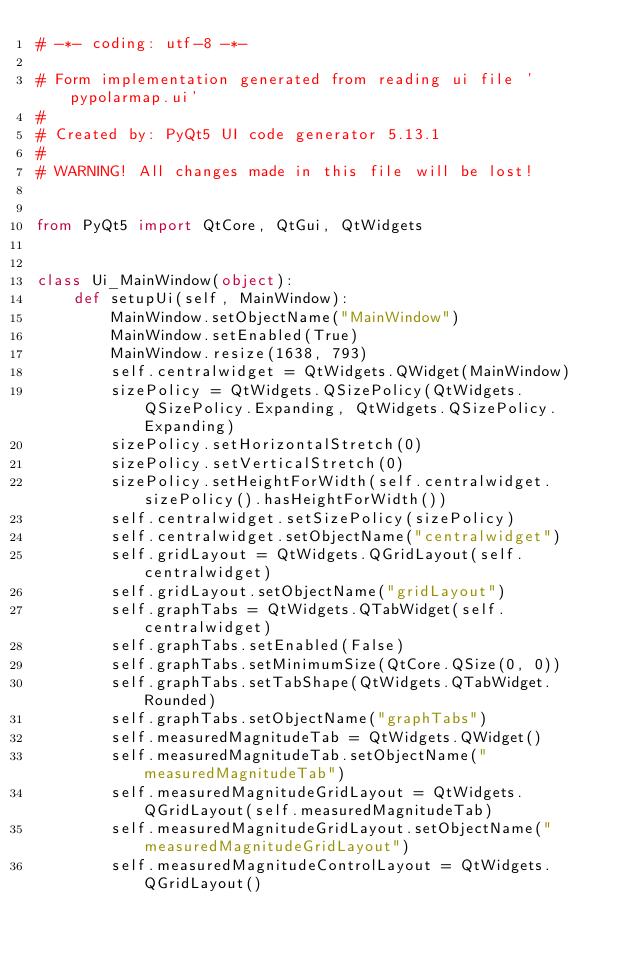Convert code to text. <code><loc_0><loc_0><loc_500><loc_500><_Python_># -*- coding: utf-8 -*-

# Form implementation generated from reading ui file 'pypolarmap.ui'
#
# Created by: PyQt5 UI code generator 5.13.1
#
# WARNING! All changes made in this file will be lost!


from PyQt5 import QtCore, QtGui, QtWidgets


class Ui_MainWindow(object):
    def setupUi(self, MainWindow):
        MainWindow.setObjectName("MainWindow")
        MainWindow.setEnabled(True)
        MainWindow.resize(1638, 793)
        self.centralwidget = QtWidgets.QWidget(MainWindow)
        sizePolicy = QtWidgets.QSizePolicy(QtWidgets.QSizePolicy.Expanding, QtWidgets.QSizePolicy.Expanding)
        sizePolicy.setHorizontalStretch(0)
        sizePolicy.setVerticalStretch(0)
        sizePolicy.setHeightForWidth(self.centralwidget.sizePolicy().hasHeightForWidth())
        self.centralwidget.setSizePolicy(sizePolicy)
        self.centralwidget.setObjectName("centralwidget")
        self.gridLayout = QtWidgets.QGridLayout(self.centralwidget)
        self.gridLayout.setObjectName("gridLayout")
        self.graphTabs = QtWidgets.QTabWidget(self.centralwidget)
        self.graphTabs.setEnabled(False)
        self.graphTabs.setMinimumSize(QtCore.QSize(0, 0))
        self.graphTabs.setTabShape(QtWidgets.QTabWidget.Rounded)
        self.graphTabs.setObjectName("graphTabs")
        self.measuredMagnitudeTab = QtWidgets.QWidget()
        self.measuredMagnitudeTab.setObjectName("measuredMagnitudeTab")
        self.measuredMagnitudeGridLayout = QtWidgets.QGridLayout(self.measuredMagnitudeTab)
        self.measuredMagnitudeGridLayout.setObjectName("measuredMagnitudeGridLayout")
        self.measuredMagnitudeControlLayout = QtWidgets.QGridLayout()</code> 